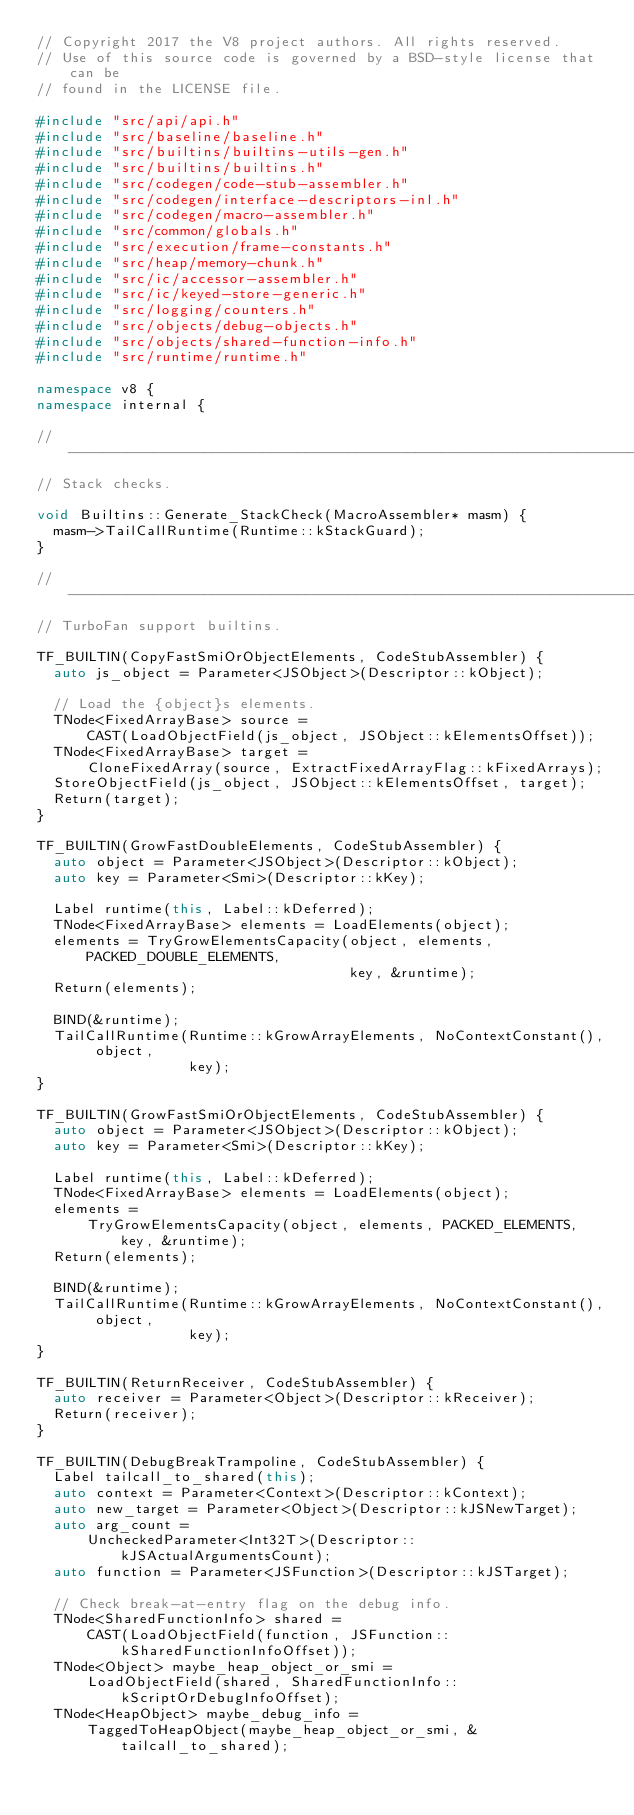Convert code to text. <code><loc_0><loc_0><loc_500><loc_500><_C++_>// Copyright 2017 the V8 project authors. All rights reserved.
// Use of this source code is governed by a BSD-style license that can be
// found in the LICENSE file.

#include "src/api/api.h"
#include "src/baseline/baseline.h"
#include "src/builtins/builtins-utils-gen.h"
#include "src/builtins/builtins.h"
#include "src/codegen/code-stub-assembler.h"
#include "src/codegen/interface-descriptors-inl.h"
#include "src/codegen/macro-assembler.h"
#include "src/common/globals.h"
#include "src/execution/frame-constants.h"
#include "src/heap/memory-chunk.h"
#include "src/ic/accessor-assembler.h"
#include "src/ic/keyed-store-generic.h"
#include "src/logging/counters.h"
#include "src/objects/debug-objects.h"
#include "src/objects/shared-function-info.h"
#include "src/runtime/runtime.h"

namespace v8 {
namespace internal {

// -----------------------------------------------------------------------------
// Stack checks.

void Builtins::Generate_StackCheck(MacroAssembler* masm) {
  masm->TailCallRuntime(Runtime::kStackGuard);
}

// -----------------------------------------------------------------------------
// TurboFan support builtins.

TF_BUILTIN(CopyFastSmiOrObjectElements, CodeStubAssembler) {
  auto js_object = Parameter<JSObject>(Descriptor::kObject);

  // Load the {object}s elements.
  TNode<FixedArrayBase> source =
      CAST(LoadObjectField(js_object, JSObject::kElementsOffset));
  TNode<FixedArrayBase> target =
      CloneFixedArray(source, ExtractFixedArrayFlag::kFixedArrays);
  StoreObjectField(js_object, JSObject::kElementsOffset, target);
  Return(target);
}

TF_BUILTIN(GrowFastDoubleElements, CodeStubAssembler) {
  auto object = Parameter<JSObject>(Descriptor::kObject);
  auto key = Parameter<Smi>(Descriptor::kKey);

  Label runtime(this, Label::kDeferred);
  TNode<FixedArrayBase> elements = LoadElements(object);
  elements = TryGrowElementsCapacity(object, elements, PACKED_DOUBLE_ELEMENTS,
                                     key, &runtime);
  Return(elements);

  BIND(&runtime);
  TailCallRuntime(Runtime::kGrowArrayElements, NoContextConstant(), object,
                  key);
}

TF_BUILTIN(GrowFastSmiOrObjectElements, CodeStubAssembler) {
  auto object = Parameter<JSObject>(Descriptor::kObject);
  auto key = Parameter<Smi>(Descriptor::kKey);

  Label runtime(this, Label::kDeferred);
  TNode<FixedArrayBase> elements = LoadElements(object);
  elements =
      TryGrowElementsCapacity(object, elements, PACKED_ELEMENTS, key, &runtime);
  Return(elements);

  BIND(&runtime);
  TailCallRuntime(Runtime::kGrowArrayElements, NoContextConstant(), object,
                  key);
}

TF_BUILTIN(ReturnReceiver, CodeStubAssembler) {
  auto receiver = Parameter<Object>(Descriptor::kReceiver);
  Return(receiver);
}

TF_BUILTIN(DebugBreakTrampoline, CodeStubAssembler) {
  Label tailcall_to_shared(this);
  auto context = Parameter<Context>(Descriptor::kContext);
  auto new_target = Parameter<Object>(Descriptor::kJSNewTarget);
  auto arg_count =
      UncheckedParameter<Int32T>(Descriptor::kJSActualArgumentsCount);
  auto function = Parameter<JSFunction>(Descriptor::kJSTarget);

  // Check break-at-entry flag on the debug info.
  TNode<SharedFunctionInfo> shared =
      CAST(LoadObjectField(function, JSFunction::kSharedFunctionInfoOffset));
  TNode<Object> maybe_heap_object_or_smi =
      LoadObjectField(shared, SharedFunctionInfo::kScriptOrDebugInfoOffset);
  TNode<HeapObject> maybe_debug_info =
      TaggedToHeapObject(maybe_heap_object_or_smi, &tailcall_to_shared);</code> 